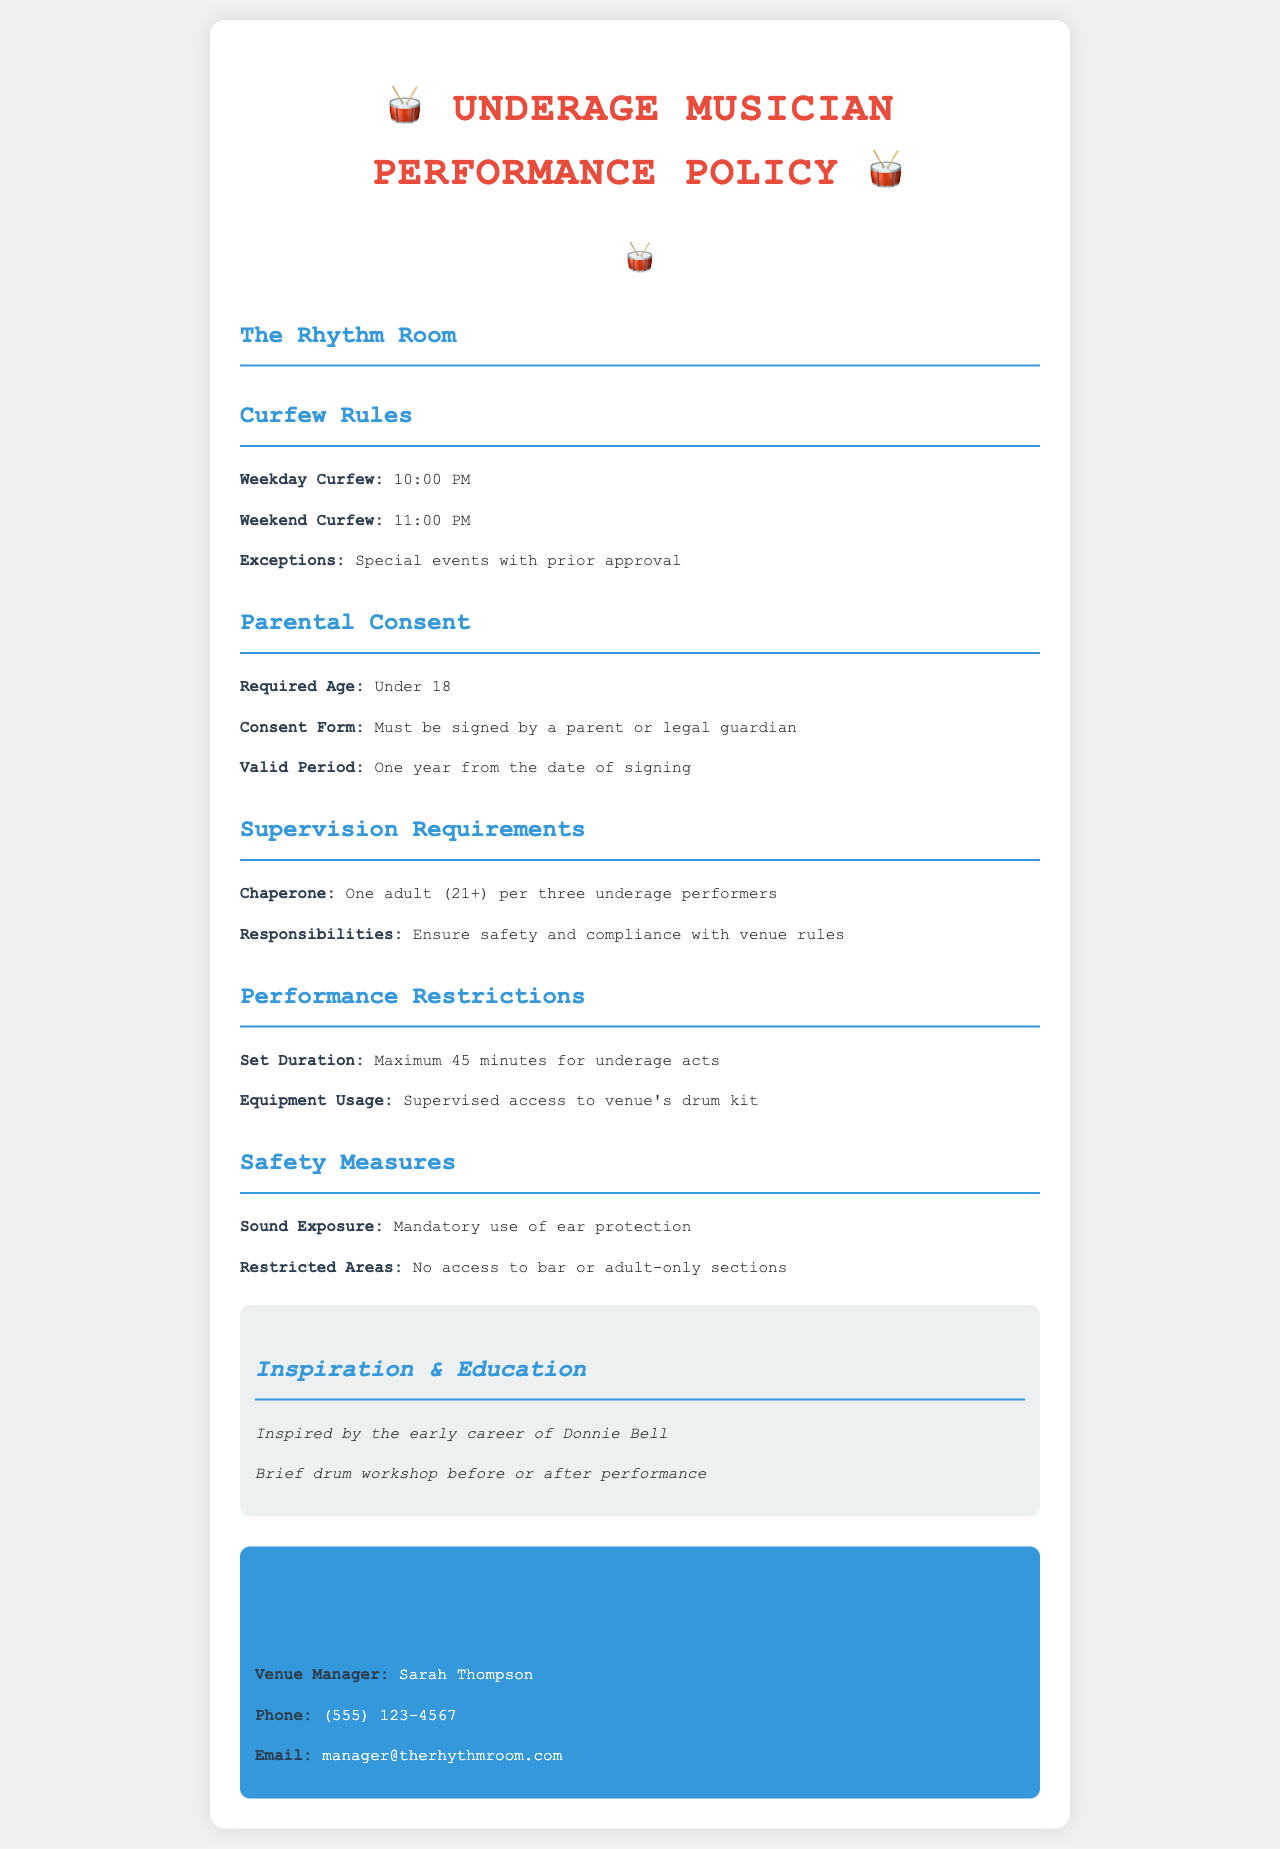What is the weekday curfew for underage musicians? The weekday curfew is specified in the "Curfew Rules" section of the document.
Answer: 10:00 PM What is the maximum set duration for underage acts? This information is found in the "Performance Restrictions" section, which outlines the set duration for performances.
Answer: 45 minutes Who must sign the consent form for underage musicians? The "Parental Consent" section details who needs to sign the consent form.
Answer: Parent or legal guardian How many underage performers can one chaperone supervise? The "Supervision Requirements" section gives the ratio of chaperones to underage performers.
Answer: Three What is the valid period for the signed consent form? This information is located in the "Parental Consent" section of the document.
Answer: One year What is required for sound exposure safety? The "Safety Measures" section mentions mandatory requirements for safety concerning sound exposure.
Answer: Ear protection What time does the weekend curfew end? The weekend curfew is outlined in the "Curfew Rules" section.
Answer: 11:00 PM What section addresses supervision responsibilities? The responsibilities are discussed in the "Supervision Requirements" section of the document.
Answer: Supervision Requirements What is the venue manager's name? The name of the venue manager is provided in the "Contact Information" section.
Answer: Sarah Thompson 